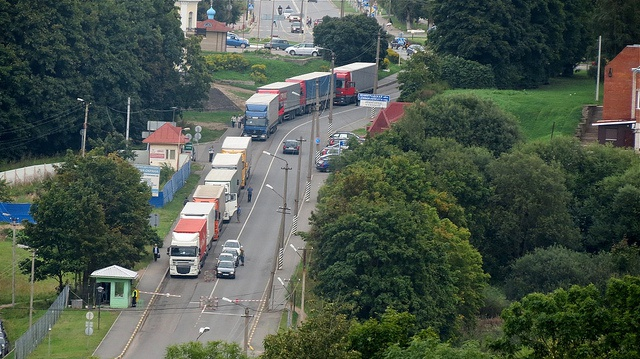Describe the objects in this image and their specific colors. I can see truck in black, white, darkgray, gray, and salmon tones, truck in black, gray, white, and darkblue tones, truck in black, lightgray, and gray tones, truck in black, lightgray, darkgray, and gray tones, and truck in black, gray, blue, and white tones in this image. 